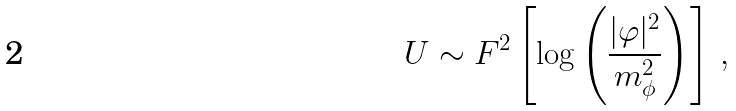<formula> <loc_0><loc_0><loc_500><loc_500>U \sim F ^ { 2 } \left [ \log \left ( \frac { | \varphi | ^ { 2 } } { m ^ { 2 } _ { \phi } } \right ) \right ] \, ,</formula> 